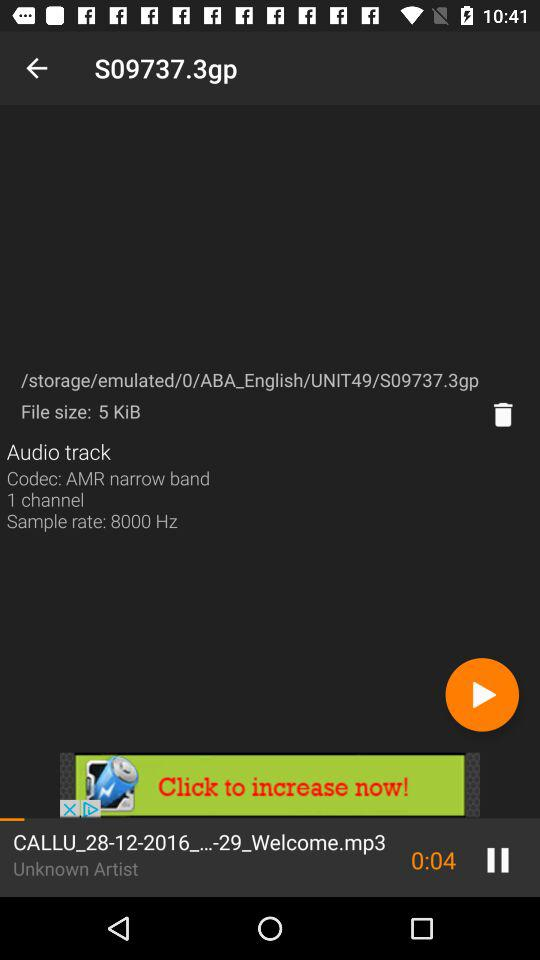How many channels are given? There is 1 channel that is given. 